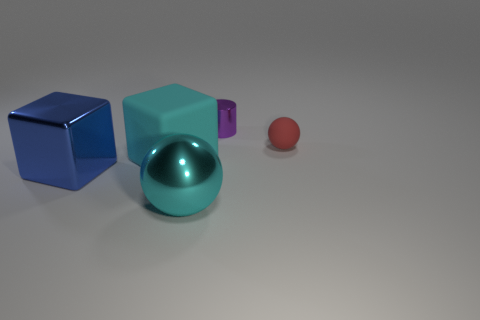Are there any other things that are made of the same material as the purple cylinder?
Offer a very short reply. Yes. Are any matte balls visible?
Your answer should be very brief. Yes. Are the cube on the left side of the large cyan block and the red thing made of the same material?
Provide a succinct answer. No. Are there any cyan objects of the same shape as the big blue object?
Keep it short and to the point. Yes. Are there the same number of metallic things that are in front of the red ball and purple rubber balls?
Your answer should be compact. No. There is a large cyan thing to the left of the large cyan thing in front of the large cyan matte cube; what is its material?
Offer a terse response. Rubber. There is a blue object; what shape is it?
Give a very brief answer. Cube. Are there the same number of red balls on the left side of the red matte sphere and large cubes that are behind the blue object?
Provide a short and direct response. No. Do the metallic thing left of the big cyan sphere and the tiny ball that is behind the rubber cube have the same color?
Offer a terse response. No. Are there more big metal balls on the left side of the tiny metallic cylinder than green metal objects?
Offer a very short reply. Yes. 